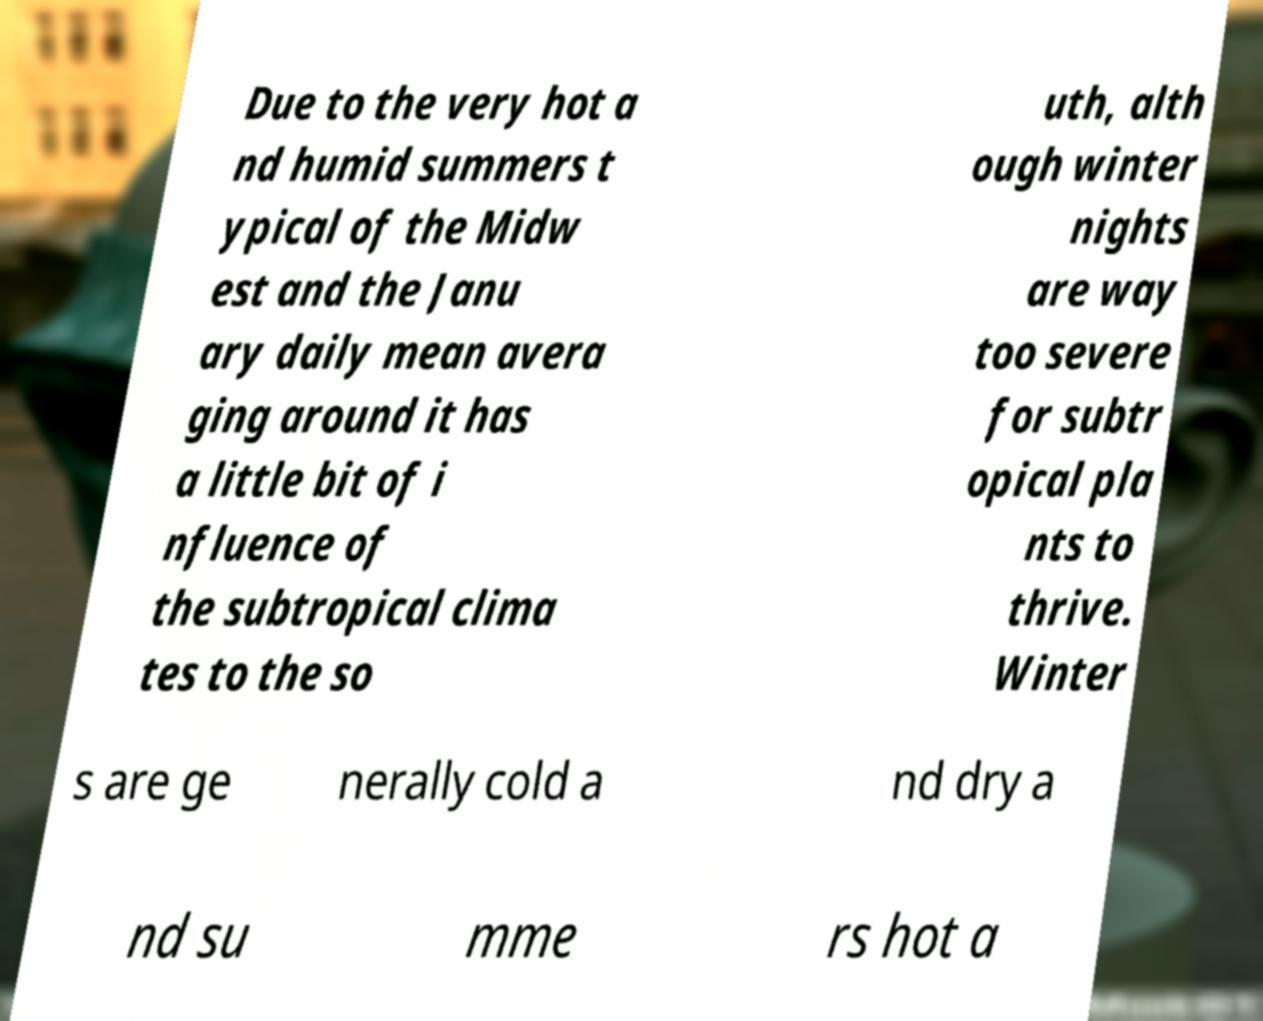Could you extract and type out the text from this image? Due to the very hot a nd humid summers t ypical of the Midw est and the Janu ary daily mean avera ging around it has a little bit of i nfluence of the subtropical clima tes to the so uth, alth ough winter nights are way too severe for subtr opical pla nts to thrive. Winter s are ge nerally cold a nd dry a nd su mme rs hot a 